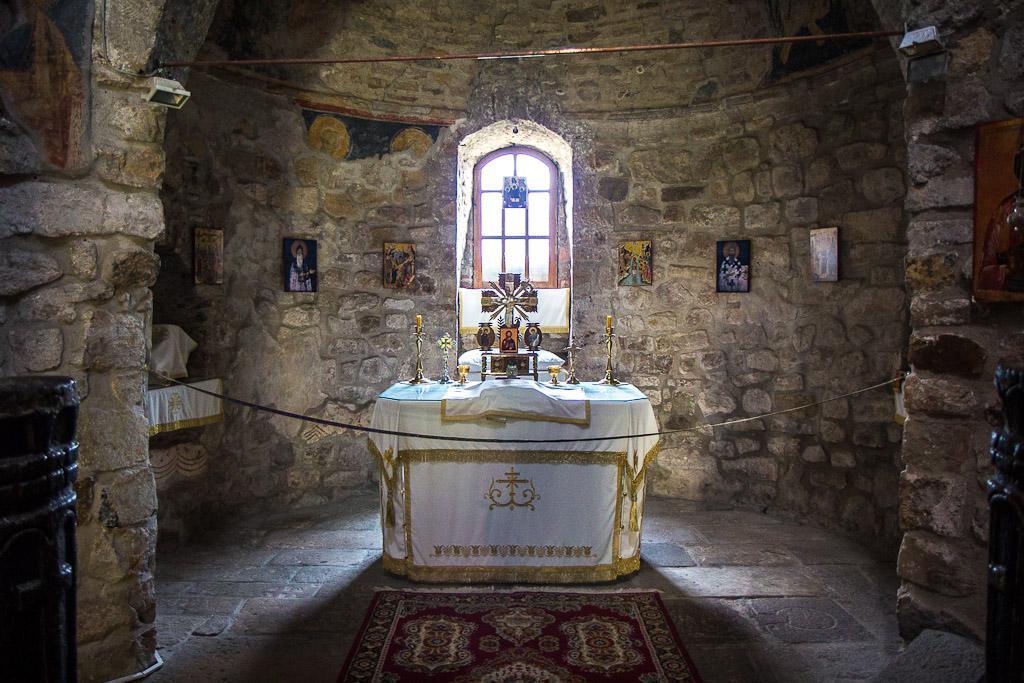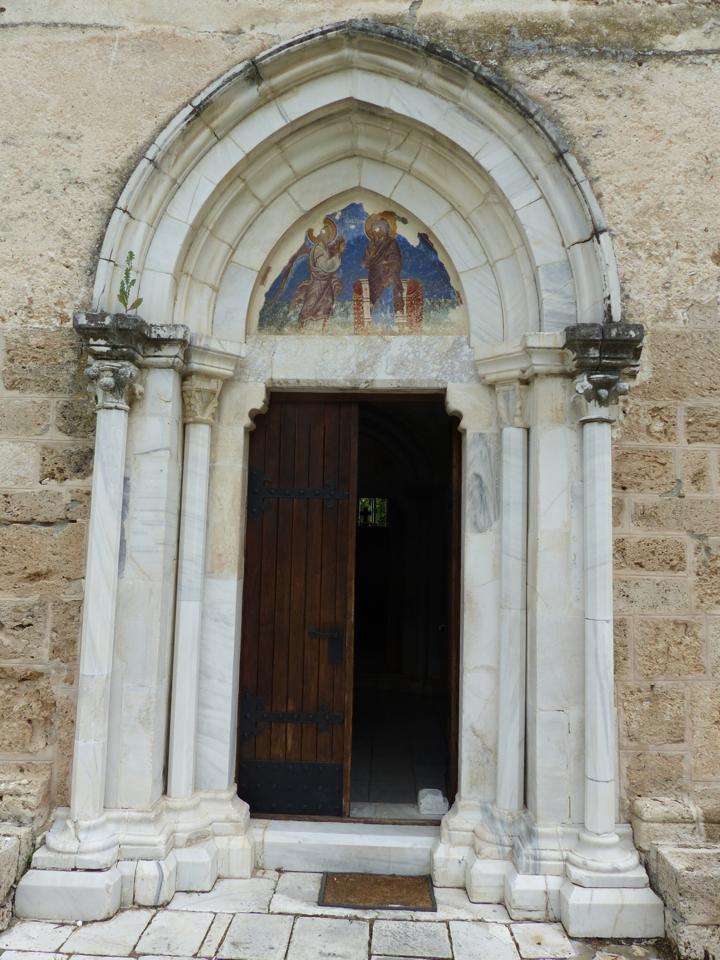The first image is the image on the left, the second image is the image on the right. For the images displayed, is the sentence "Multiple people stand in front of an arch in one image." factually correct? Answer yes or no. No. The first image is the image on the left, the second image is the image on the right. For the images displayed, is the sentence "In one image, an ornate arched entry with columns and a colored painting under the arch is set in an outside stone wall of a building." factually correct? Answer yes or no. Yes. 